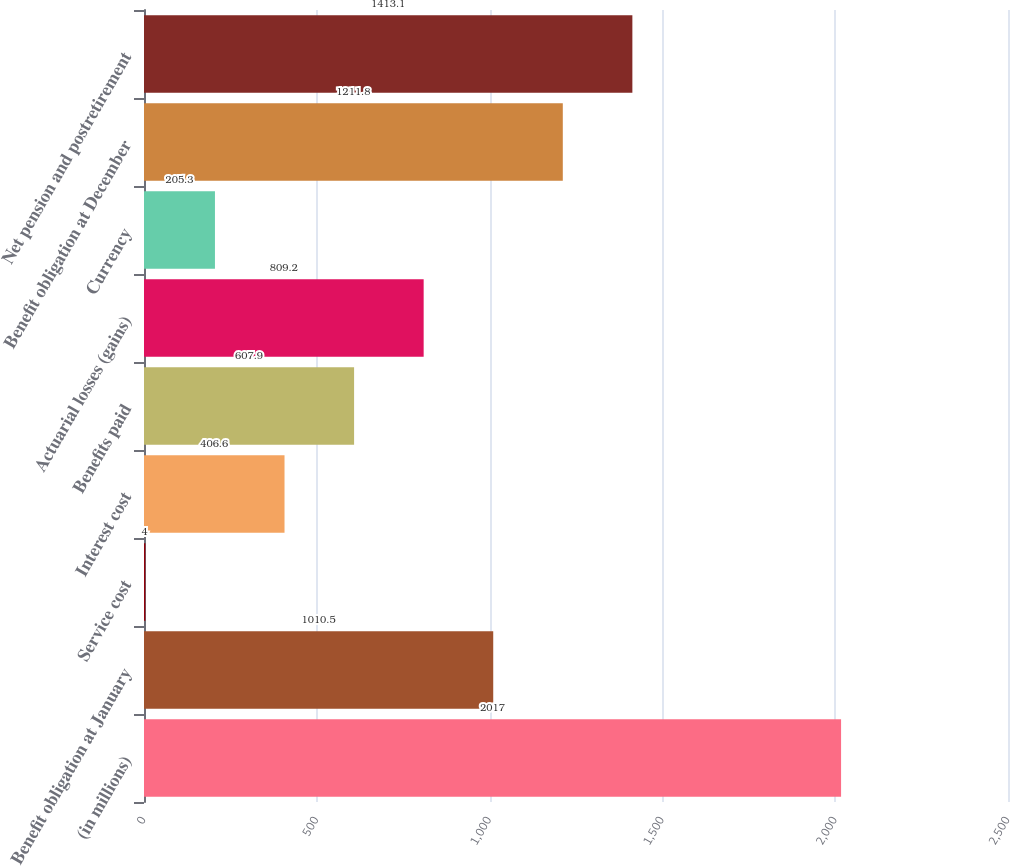Convert chart. <chart><loc_0><loc_0><loc_500><loc_500><bar_chart><fcel>(in millions)<fcel>Benefit obligation at January<fcel>Service cost<fcel>Interest cost<fcel>Benefits paid<fcel>Actuarial losses (gains)<fcel>Currency<fcel>Benefit obligation at December<fcel>Net pension and postretirement<nl><fcel>2017<fcel>1010.5<fcel>4<fcel>406.6<fcel>607.9<fcel>809.2<fcel>205.3<fcel>1211.8<fcel>1413.1<nl></chart> 